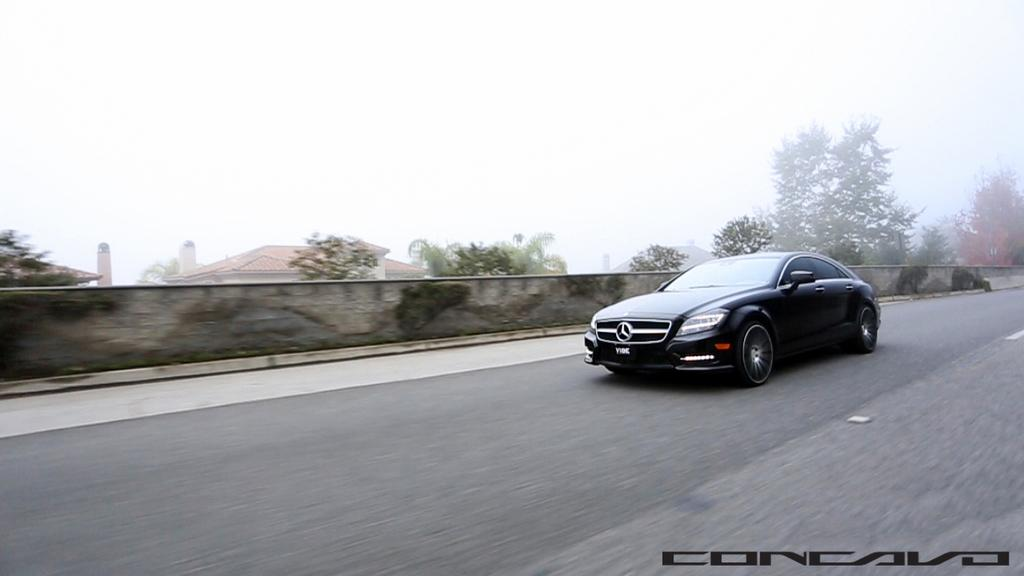What is the main subject of the image? There is a vehicle on the road in the image. What can be seen in the background of the image? In the background of the image, there is a fencing wall, trees, buildings, and the sky. Is there any text present in the image? Yes, there is some text at the bottom of the image. What type of wrench is being used to solve the arithmetic problem in the image? There is no wrench or arithmetic problem present in the image. How does the vehicle look in the image? The question is not specific enough to answer definitively. The vehicle's appearance is not described in the provided facts. 